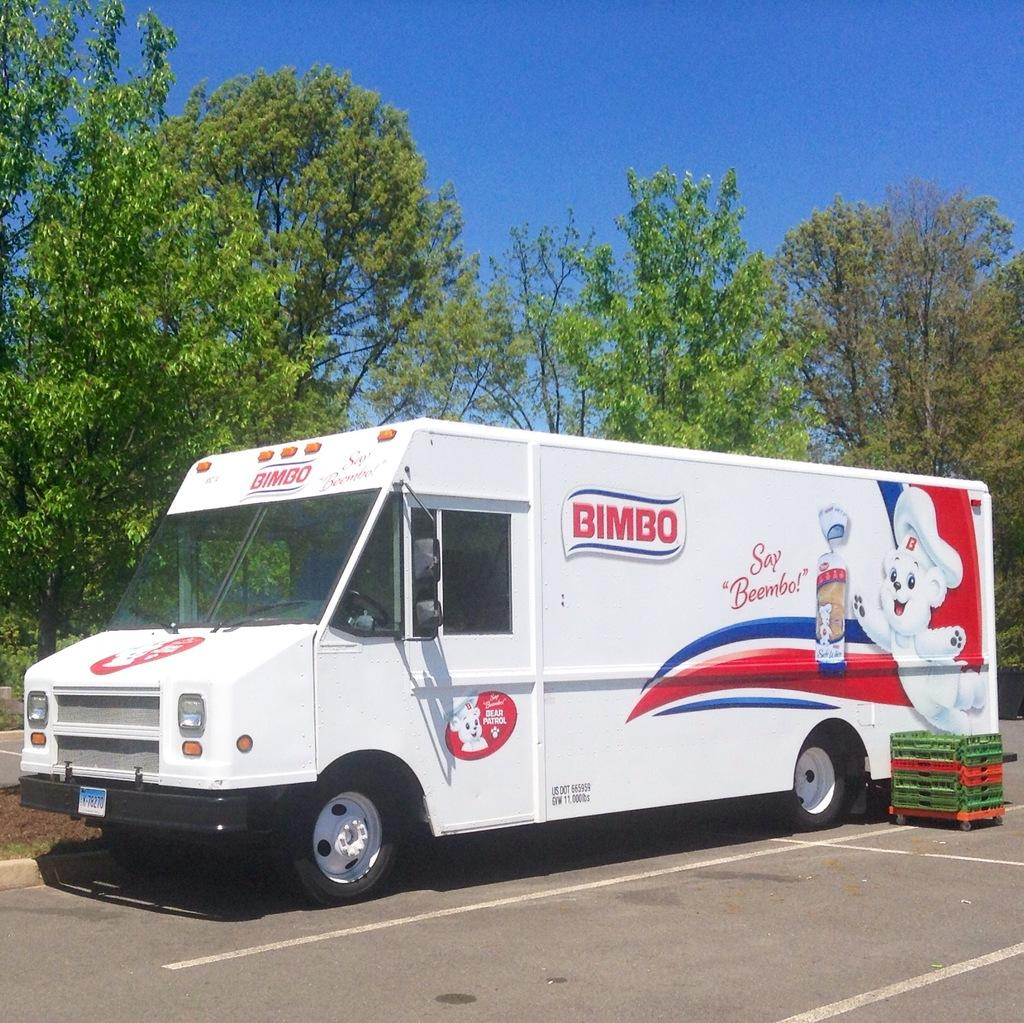What type of vehicle is in the image? There is a white van in the image. What is unique about the van's appearance? The van has a painting on it. What is the purpose of the basket with wheels in the image? The basket with wheels might be used for carrying items or as a mode of transportation. What can be seen on the trees in the image? The trees have branches and leaves in the image. What type of ornament is hanging from the branches of the trees in the image? There is no ornament hanging from the branches of the trees in the image. How many bubbles can be seen floating around the van in the image? There are no bubbles present in the image. 